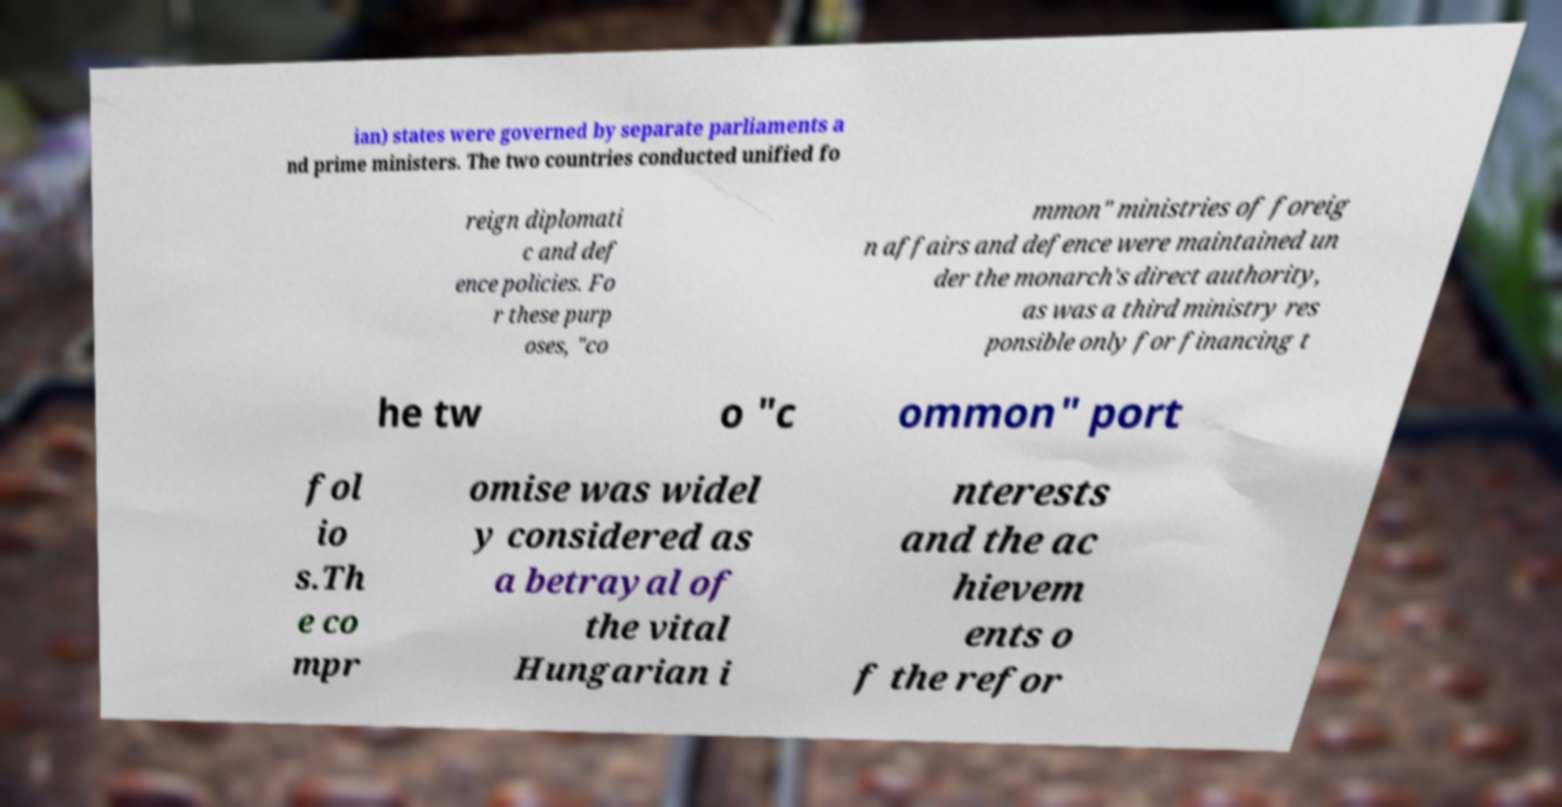I need the written content from this picture converted into text. Can you do that? ian) states were governed by separate parliaments a nd prime ministers. The two countries conducted unified fo reign diplomati c and def ence policies. Fo r these purp oses, "co mmon" ministries of foreig n affairs and defence were maintained un der the monarch's direct authority, as was a third ministry res ponsible only for financing t he tw o "c ommon" port fol io s.Th e co mpr omise was widel y considered as a betrayal of the vital Hungarian i nterests and the ac hievem ents o f the refor 